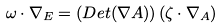<formula> <loc_0><loc_0><loc_500><loc_500>\omega \cdot \nabla _ { E } = ( D e t ( \nabla A ) ) \left ( \zeta \cdot \nabla _ { A } \right )</formula> 